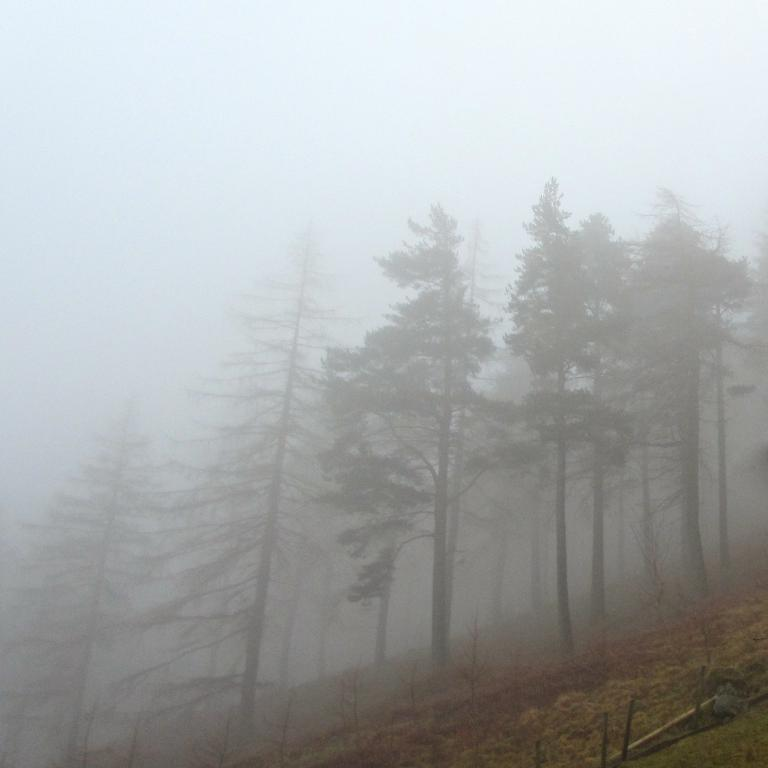What type of vegetation is present at the bottom of the image? There are plants at the bottom of the image. What can be seen in the background of the image? There are trees and fog visible in the background of the image. What type of ray is visible on the tray in the image? There is no ray or tray present in the image. Can you describe the volleyball game happening in the background of the image? There is no volleyball game present in the image; it features plants, trees, and fog. 